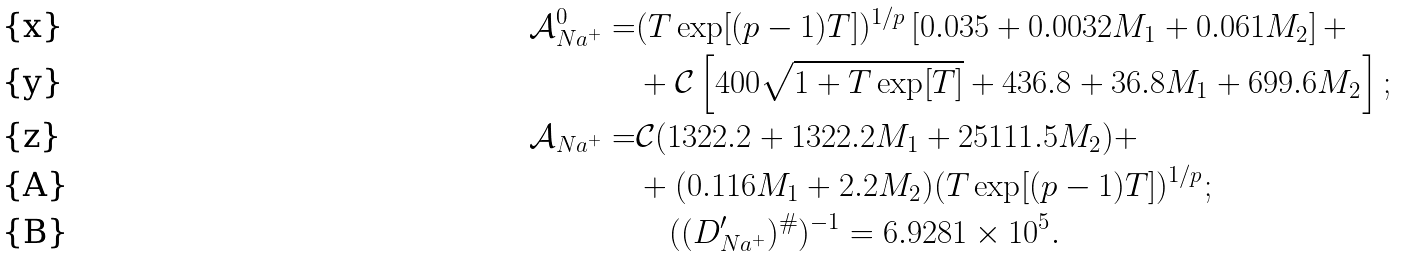Convert formula to latex. <formula><loc_0><loc_0><loc_500><loc_500>\mathcal { A } ^ { 0 } _ { N a ^ { + } } = & ( T \exp [ ( p - 1 ) T ] ) ^ { 1 / p } \left [ 0 . 0 3 5 + 0 . 0 0 3 2 M _ { 1 } + 0 . 0 6 1 M _ { 2 } \right ] + \\ & + \mathcal { C } \left [ 4 0 0 \sqrt { 1 + T \exp [ T ] } + 4 3 6 . 8 + 3 6 . 8 M _ { 1 } + 6 9 9 . 6 M _ { 2 } \right ] ; \\ \mathcal { A } _ { N a ^ { + } } = & \mathcal { C } ( 1 3 2 2 . 2 + 1 3 2 2 . 2 M _ { 1 } + 2 5 1 1 1 . 5 M _ { 2 } ) + \\ & + ( 0 . 1 1 6 M _ { 1 } + 2 . 2 M _ { 2 } ) ( T \exp [ ( p - 1 ) T ] ) ^ { 1 / p } ; \\ & \quad ( ( D _ { N a ^ { + } } ^ { \prime } ) ^ { \# } ) ^ { - 1 } = 6 . 9 2 8 1 \times 1 0 ^ { 5 } .</formula> 